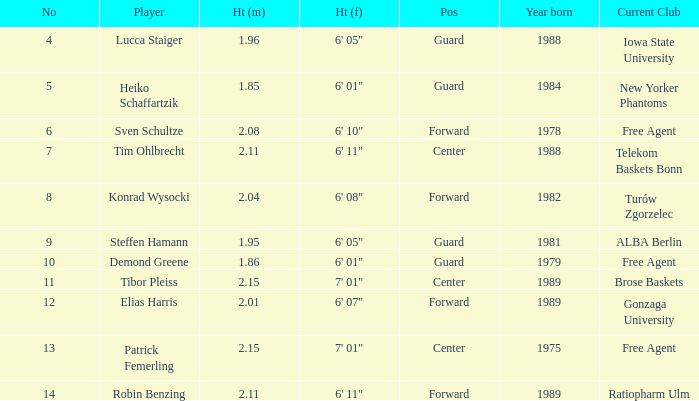Which competitor stands at Heiko Schaffartzik. 